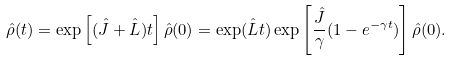<formula> <loc_0><loc_0><loc_500><loc_500>\hat { \rho } ( t ) = \exp \left [ ( \hat { J } + \hat { L } ) t \right ] \hat { \rho } ( 0 ) = \exp ( \hat { L } t ) \exp \left [ \frac { \hat { J } } { \gamma } ( 1 - e ^ { - \gamma t } ) \right ] \hat { \rho } ( 0 ) .</formula> 